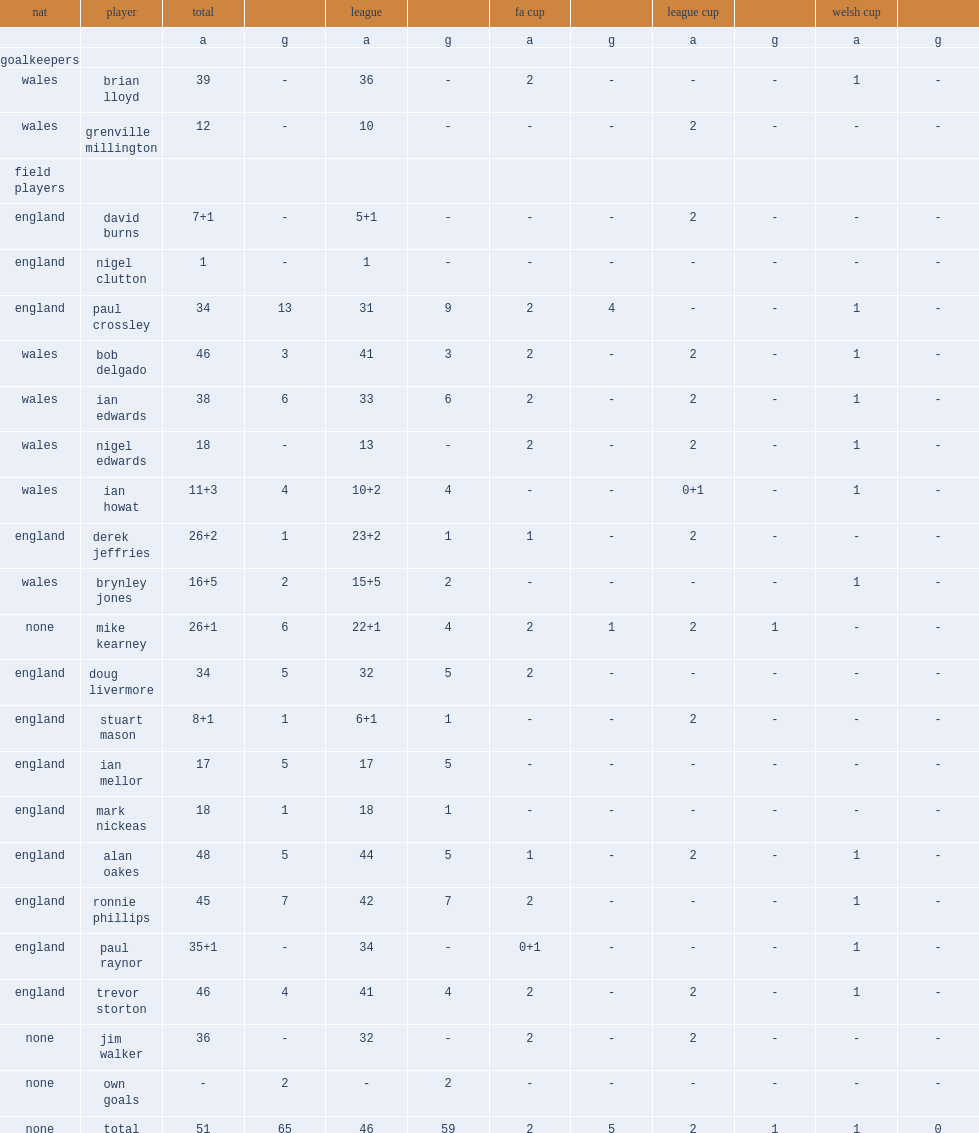List the matches that chester f.c. season competed in. Fa cup league cup welsh cup. I'm looking to parse the entire table for insights. Could you assist me with that? {'header': ['nat', 'player', 'total', '', 'league', '', 'fa cup', '', 'league cup', '', 'welsh cup', ''], 'rows': [['', '', 'a', 'g', 'a', 'g', 'a', 'g', 'a', 'g', 'a', 'g'], ['goalkeepers', '', '', '', '', '', '', '', '', '', '', ''], ['wales', 'brian lloyd', '39', '-', '36', '-', '2', '-', '-', '-', '1', '-'], ['wales', 'grenville millington', '12', '-', '10', '-', '-', '-', '2', '-', '-', '-'], ['field players', '', '', '', '', '', '', '', '', '', '', ''], ['england', 'david burns', '7+1', '-', '5+1', '-', '-', '-', '2', '-', '-', '-'], ['england', 'nigel clutton', '1', '-', '1', '-', '-', '-', '-', '-', '-', '-'], ['england', 'paul crossley', '34', '13', '31', '9', '2', '4', '-', '-', '1', '-'], ['wales', 'bob delgado', '46', '3', '41', '3', '2', '-', '2', '-', '1', '-'], ['wales', 'ian edwards', '38', '6', '33', '6', '2', '-', '2', '-', '1', '-'], ['wales', 'nigel edwards', '18', '-', '13', '-', '2', '-', '2', '-', '1', '-'], ['wales', 'ian howat', '11+3', '4', '10+2', '4', '-', '-', '0+1', '-', '1', '-'], ['england', 'derek jeffries', '26+2', '1', '23+2', '1', '1', '-', '2', '-', '-', '-'], ['wales', 'brynley jones', '16+5', '2', '15+5', '2', '-', '-', '-', '-', '1', '-'], ['none', 'mike kearney', '26+1', '6', '22+1', '4', '2', '1', '2', '1', '-', '-'], ['england', 'doug livermore', '34', '5', '32', '5', '2', '-', '-', '-', '-', '-'], ['england', 'stuart mason', '8+1', '1', '6+1', '1', '-', '-', '2', '-', '-', '-'], ['england', 'ian mellor', '17', '5', '17', '5', '-', '-', '-', '-', '-', '-'], ['england', 'mark nickeas', '18', '1', '18', '1', '-', '-', '-', '-', '-', '-'], ['england', 'alan oakes', '48', '5', '44', '5', '1', '-', '2', '-', '1', '-'], ['england', 'ronnie phillips', '45', '7', '42', '7', '2', '-', '-', '-', '1', '-'], ['england', 'paul raynor', '35+1', '-', '34', '-', '0+1', '-', '-', '-', '1', '-'], ['england', 'trevor storton', '46', '4', '41', '4', '2', '-', '2', '-', '1', '-'], ['none', 'jim walker', '36', '-', '32', '-', '2', '-', '2', '-', '-', '-'], ['none', 'own goals', '-', '2', '-', '2', '-', '-', '-', '-', '-', '-'], ['none', 'total', '51', '65', '46', '59', '2', '5', '2', '1', '1', '0']]} 